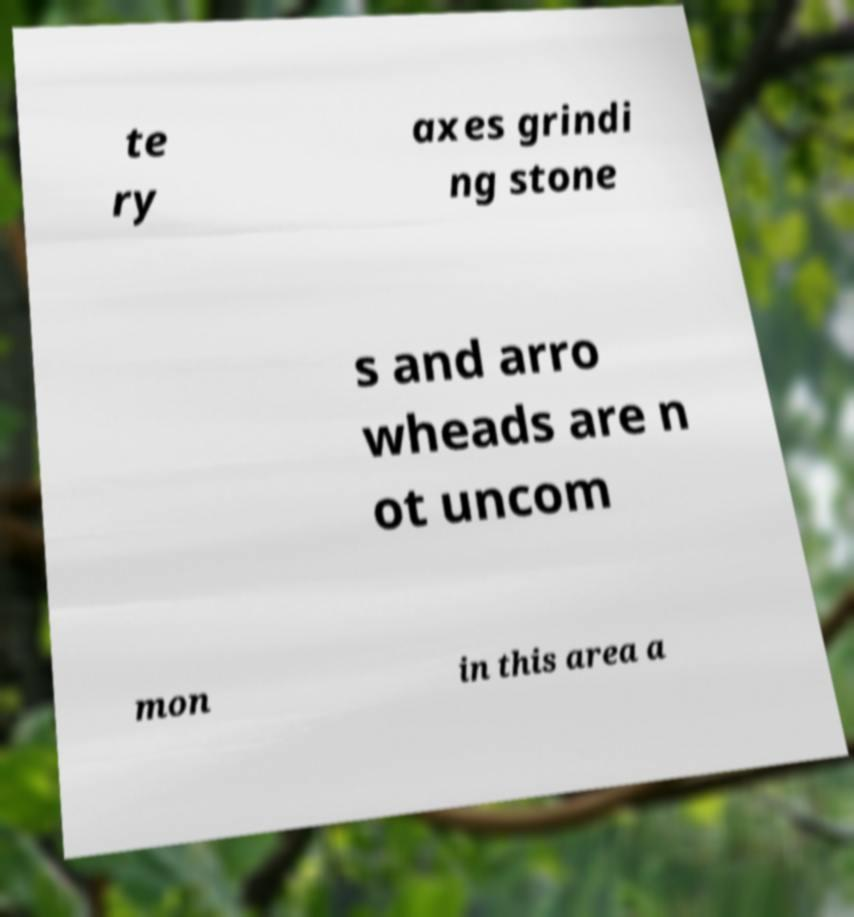Could you assist in decoding the text presented in this image and type it out clearly? te ry axes grindi ng stone s and arro wheads are n ot uncom mon in this area a 